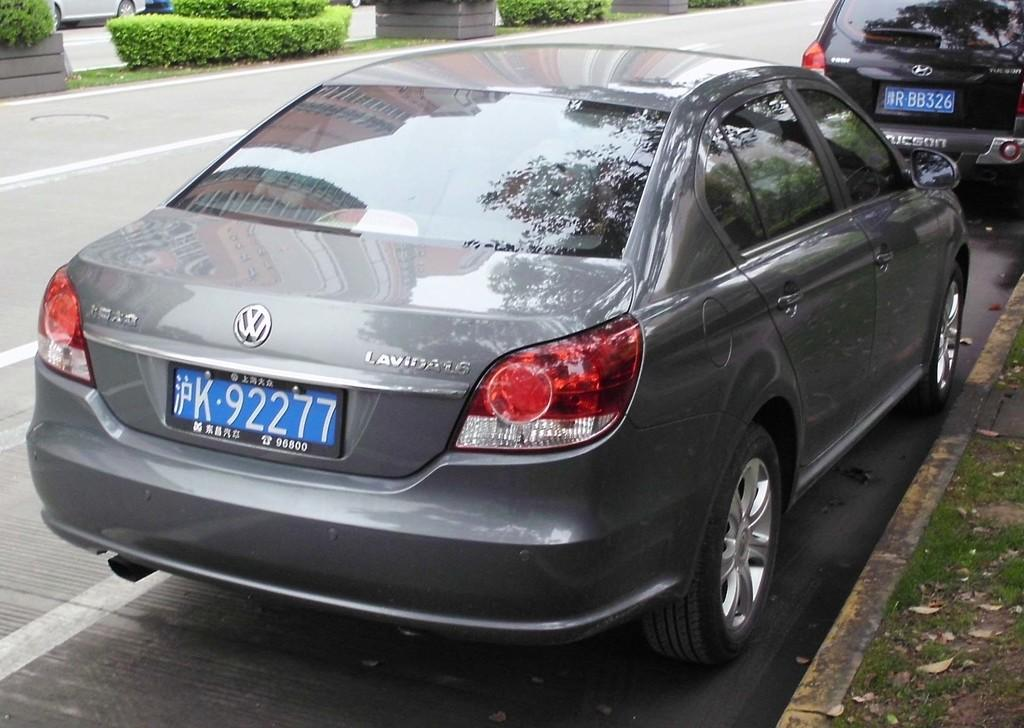Provide a one-sentence caption for the provided image. A VW Lavida is parked on a the right side of a street. 